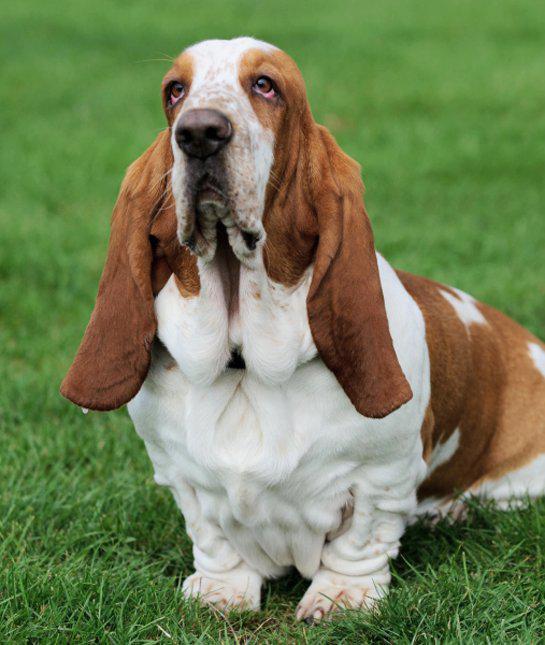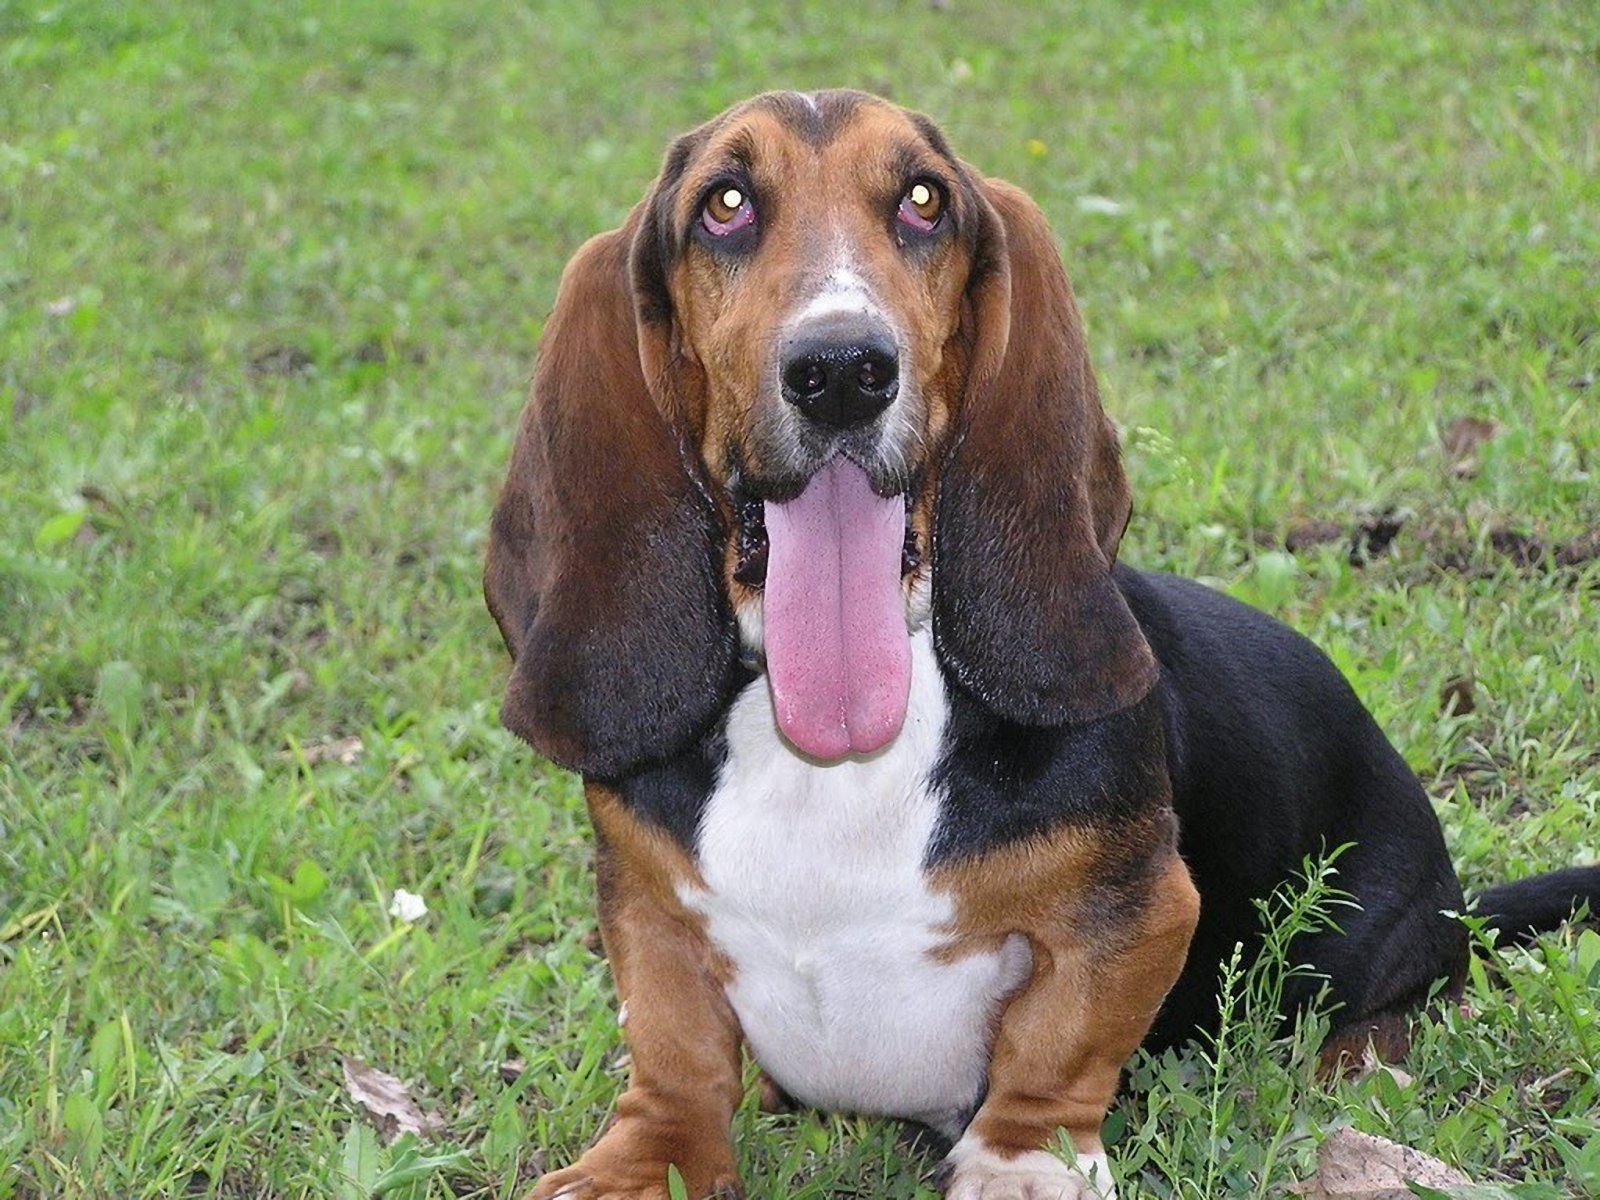The first image is the image on the left, the second image is the image on the right. Examine the images to the left and right. Is the description "One image shows a basset in profile on a white background." accurate? Answer yes or no. No. 